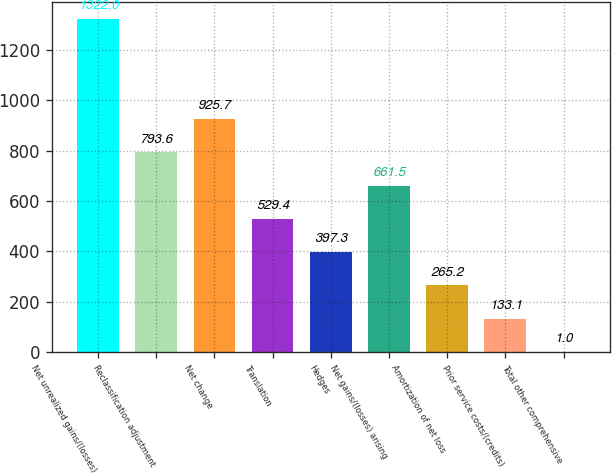Convert chart. <chart><loc_0><loc_0><loc_500><loc_500><bar_chart><fcel>Net unrealized gains/(losses)<fcel>Reclassification adjustment<fcel>Net change<fcel>Translation<fcel>Hedges<fcel>Net gains/(losses) arising<fcel>Amortization of net loss<fcel>Prior service costs/(credits)<fcel>Total other comprehensive<nl><fcel>1322<fcel>793.6<fcel>925.7<fcel>529.4<fcel>397.3<fcel>661.5<fcel>265.2<fcel>133.1<fcel>1<nl></chart> 